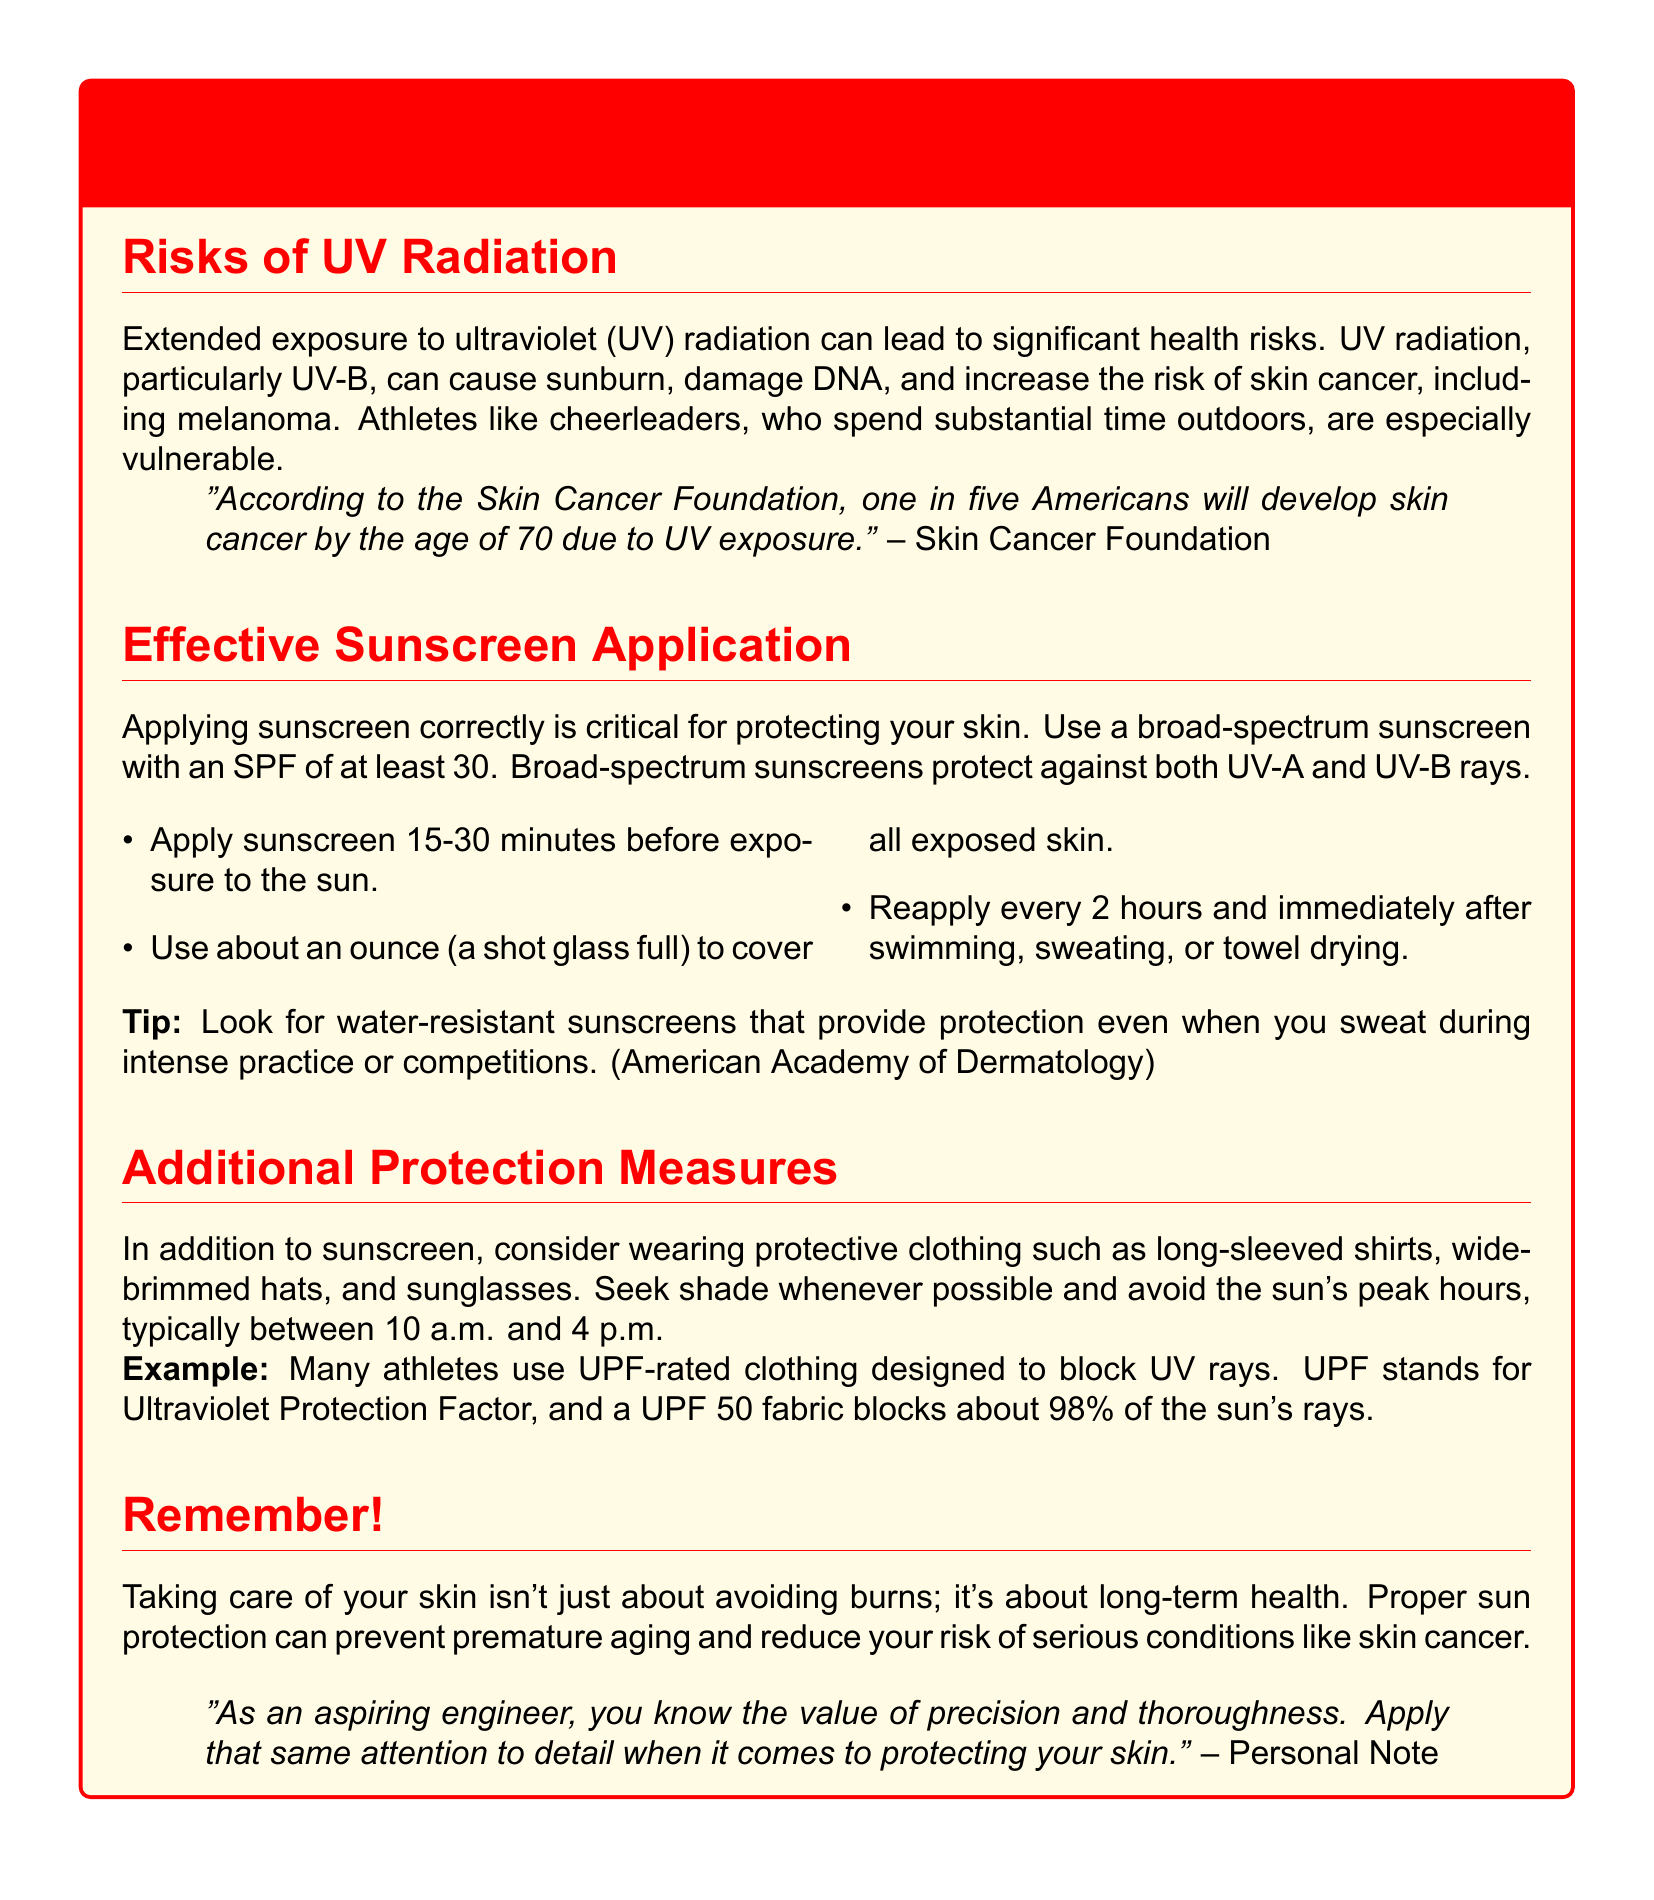What is the main health risk associated with UV radiation? The document states that UV radiation can cause sunburn, damage DNA, and increase the risk of skin cancer.
Answer: skin cancer What SPF is recommended for broad-spectrum sunscreen? The document specifically mentions using sunscreen with an SPF of at least 30.
Answer: 30 How often should sunscreen be reapplied? According to the document, sunscreen should be reapplied every 2 hours.
Answer: 2 hours What type of clothing is suggested for additional protection? The document suggests wearing UPF-rated clothing designed to block UV rays.
Answer: UPF-rated clothing Why should cheerleaders be particularly cautious about sun exposure? The document states that athletes like cheerleaders, who spend substantial time outdoors, are especially vulnerable.
Answer: especially vulnerable How long before sun exposure should sunscreen be applied? The document advises applying sunscreen 15-30 minutes before exposure to the sun.
Answer: 15-30 minutes What should you look for in a water-resistant sunscreen? The document advises looking for sunscreens that provide protection even when you sweat during intense practice or competitions.
Answer: water-resistant What is the suggested amount of sunscreen to use? The document states to use about an ounce to cover all exposed skin.
Answer: an ounce What time of day should you avoid sun exposure? The document mentions avoiding the sun's peak hours, typically between 10 a.m. and 4 p.m.
Answer: 10 a.m. and 4 p.m 